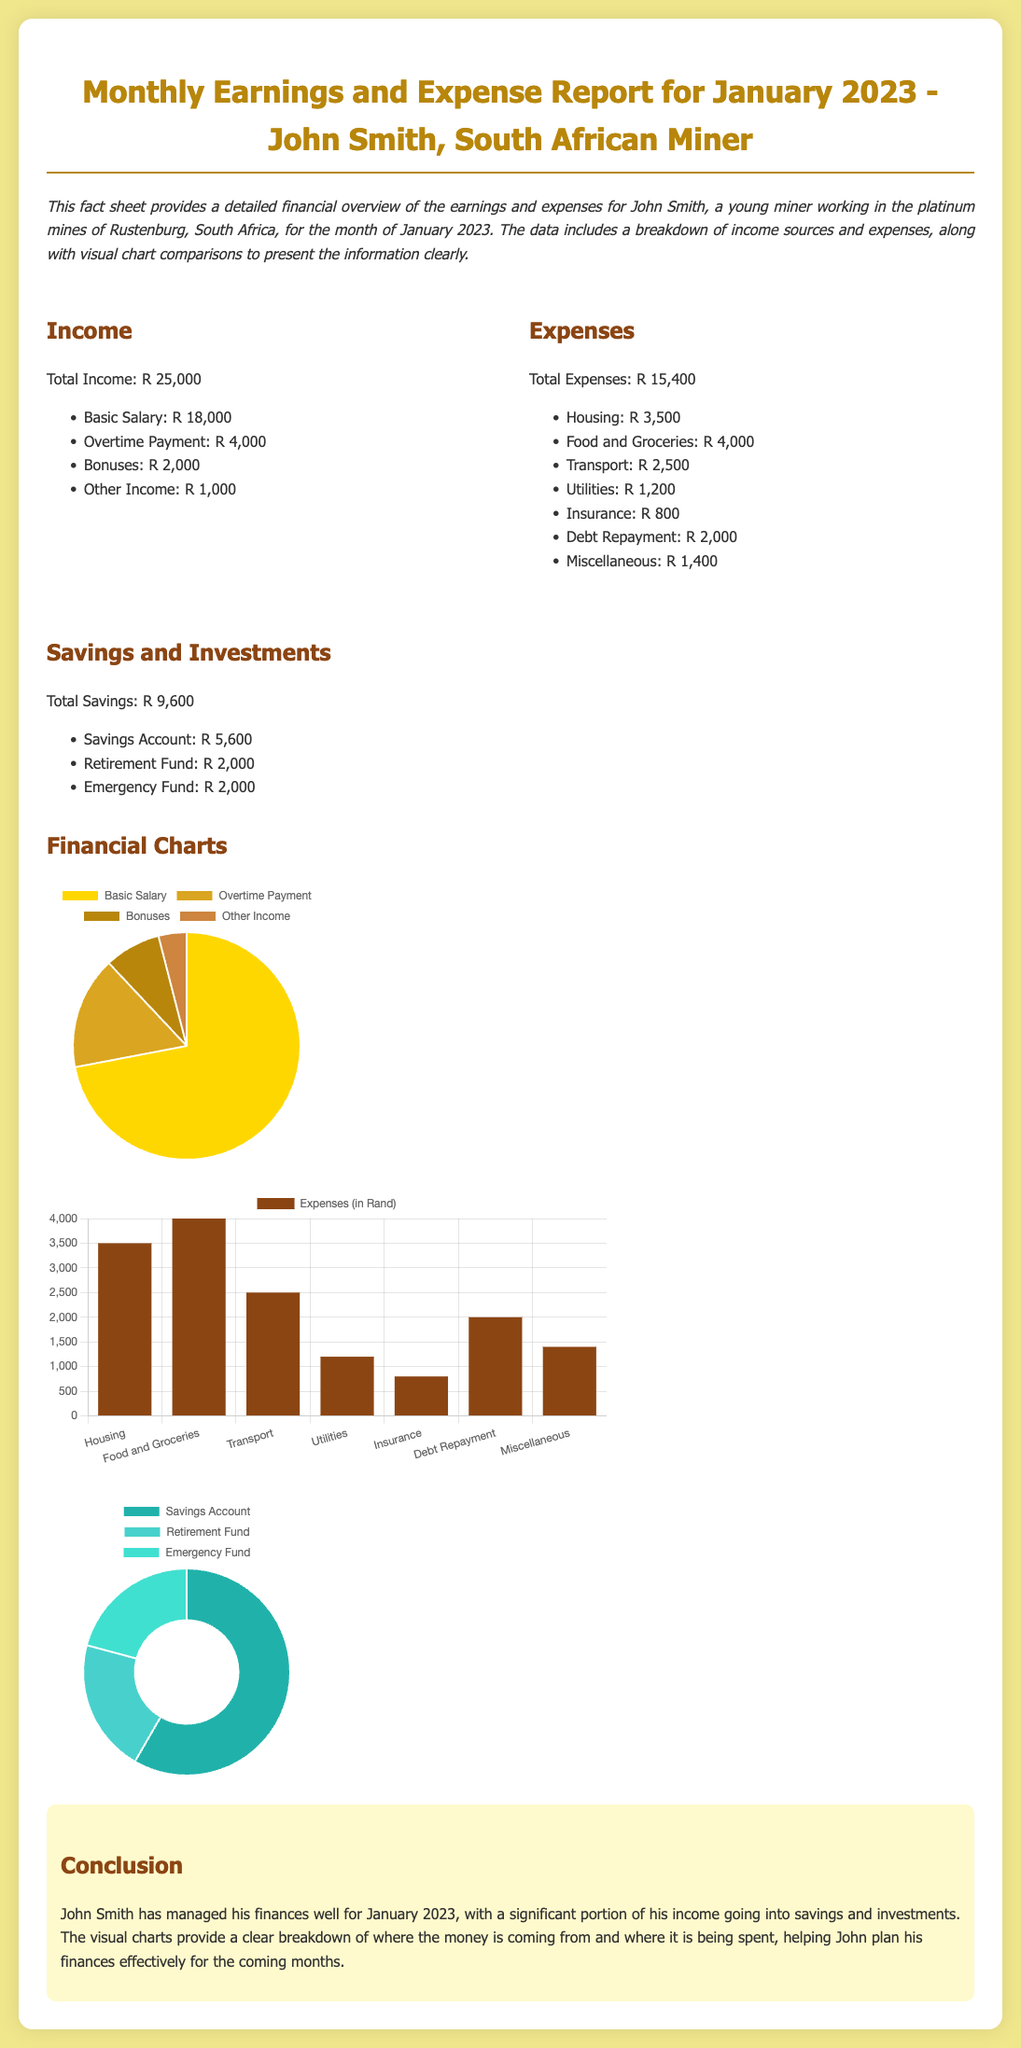What was John Smith's total income for January 2023? The total income is provided in the document as R 25,000.
Answer: R 25,000 How much did John earn from overtime payments? The document specifies that the overtime payment amounted to R 4,000.
Answer: R 4,000 What are John Smith's total expenses for January 2023? The total expenses are detailed in the document as R 15,400.
Answer: R 15,400 Which category had the highest expense? The highest expense category is Food and Groceries, with R 4,000 spent, as indicated in the document.
Answer: Food and Groceries What is the total amount John saved in January 2023? The total savings of R 9,600 are provided in the savings section of the document.
Answer: R 9,600 How many categories does the income chart display? The income chart shows 4 categories: Basic Salary, Overtime Payment, Bonuses, and Other Income.
Answer: 4 What type of chart is used to display expenses? The document shows that a bar chart is used for the expenses breakdown.
Answer: Bar chart What percentage of total income did John save? The savings of R 9,600 from total income of R 25,000 reflect a savings percentage of approximately 38%.
Answer: 38% What color represents Housing in the expenses chart? The color specified for Housing in the expenses chart is dark brown, consistent with the document's color scheme.
Answer: Dark brown 